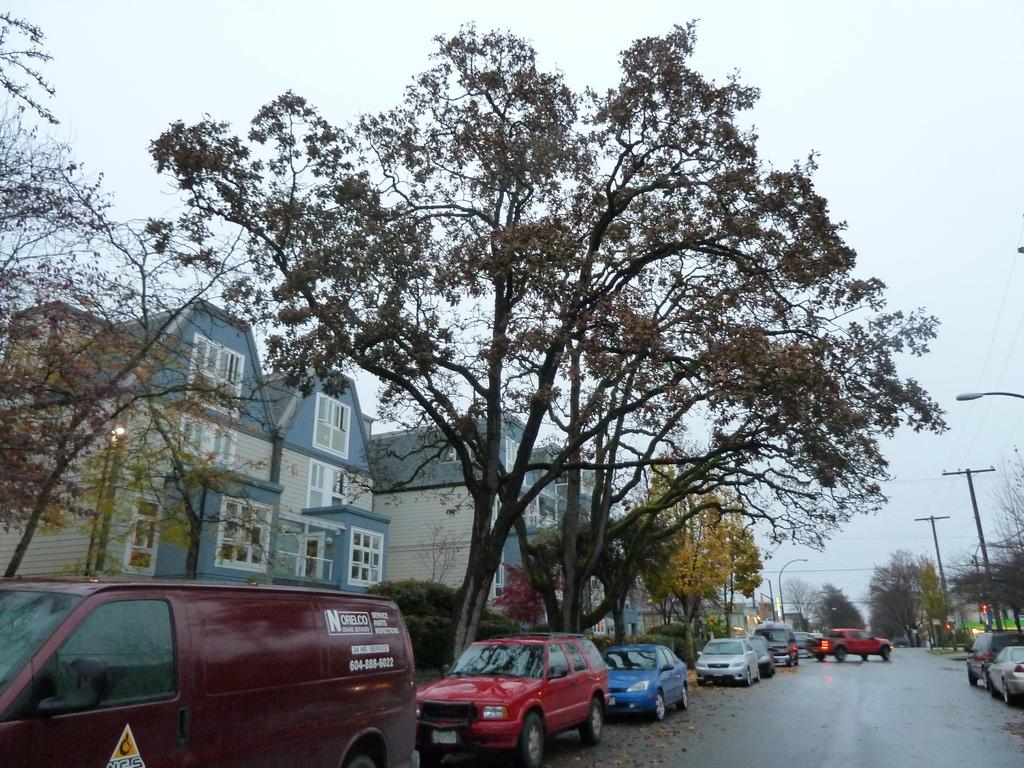What type of structures can be seen in the image? There are houses in the image. What other natural or man-made elements can be seen in the image? There are trees, electrical poles, and pole lights visible in the image. What mode of transportation can be seen in the image? Cars are parked in the image. How would you describe the weather in the image? The sky is cloudy in the image. What type of jam is being spread on the hill in the image? There is no hill or jam present in the image. 